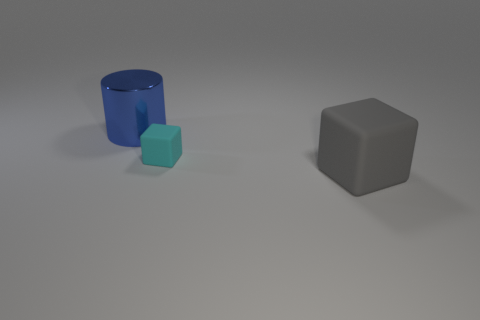Is there any other thing that has the same material as the blue cylinder?
Provide a short and direct response. No. Are there fewer things to the left of the large blue thing than blue matte spheres?
Offer a very short reply. No. There is a big thing that is to the right of the blue cylinder; what is its color?
Your response must be concise. Gray. The blue thing is what shape?
Offer a terse response. Cylinder. There is a cube left of the big object that is in front of the blue thing; is there a cyan rubber object in front of it?
Provide a short and direct response. No. The large thing that is in front of the large thing behind the big object that is in front of the large blue metal cylinder is what color?
Your answer should be very brief. Gray. What material is the gray thing that is the same shape as the small cyan matte thing?
Keep it short and to the point. Rubber. What size is the rubber object behind the large thing right of the shiny thing?
Offer a very short reply. Small. There is a blue cylinder that is left of the gray matte block; what material is it?
Ensure brevity in your answer.  Metal. The other object that is the same material as the tiny cyan thing is what size?
Your answer should be very brief. Large. 